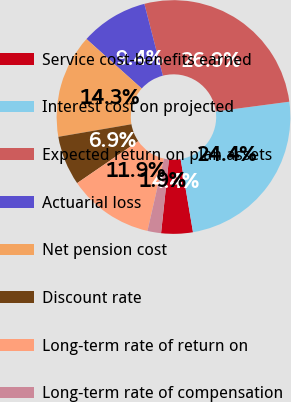Convert chart to OTSL. <chart><loc_0><loc_0><loc_500><loc_500><pie_chart><fcel>Service cost-benefits earned<fcel>Interest cost on projected<fcel>Expected return on plan assets<fcel>Actuarial loss<fcel>Net pension cost<fcel>Discount rate<fcel>Long-term rate of return on<fcel>Long-term rate of compensation<nl><fcel>4.37%<fcel>24.42%<fcel>26.92%<fcel>9.36%<fcel>14.34%<fcel>6.86%<fcel>11.85%<fcel>1.88%<nl></chart> 